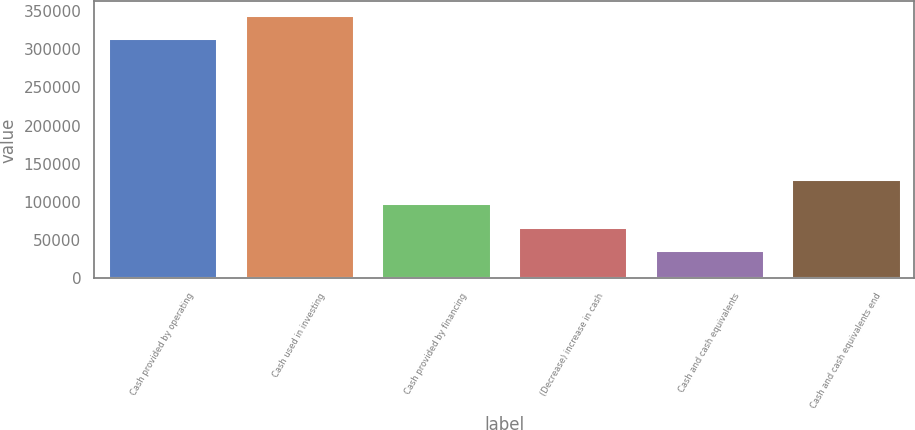Convert chart. <chart><loc_0><loc_0><loc_500><loc_500><bar_chart><fcel>Cash provided by operating<fcel>Cash used in investing<fcel>Cash provided by financing<fcel>(Decrease) increase in cash<fcel>Cash and cash equivalents<fcel>Cash and cash equivalents end<nl><fcel>314498<fcel>345319<fcel>98630<fcel>67809<fcel>36988<fcel>129451<nl></chart> 